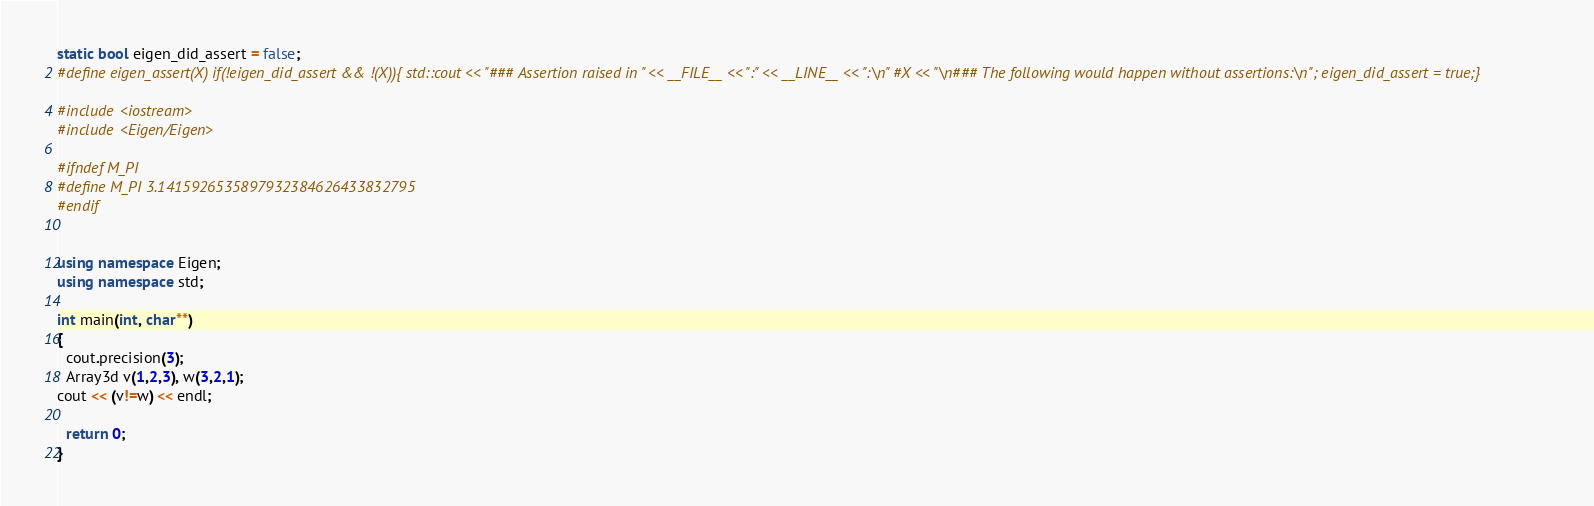<code> <loc_0><loc_0><loc_500><loc_500><_C++_>static bool eigen_did_assert = false;
#define eigen_assert(X) if(!eigen_did_assert && !(X)){ std::cout << "### Assertion raised in " << __FILE__ << ":" << __LINE__ << ":\n" #X << "\n### The following would happen without assertions:\n"; eigen_did_assert = true;}

#include <iostream>
#include <Eigen/Eigen>

#ifndef M_PI
#define M_PI 3.1415926535897932384626433832795
#endif


using namespace Eigen;
using namespace std;

int main(int, char**)
{
  cout.precision(3);
  Array3d v(1,2,3), w(3,2,1);
cout << (v!=w) << endl;

  return 0;
}
</code> 